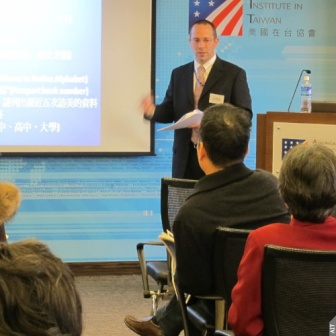Can you imagine a creative backstory for the presenter in the image? Imagine the presenter in the image is a former diplomat turned educator. He spent years working in various international roles, bridging gaps between cultures and languages. After retiring from his diplomatic career, he pursued a passion for teaching and now regularly gives lectures on global politics and international relations. His presentations are always insightful, drawing from his rich reservoir of experience and stories from around the world. Today, he is sharing his expertise with a group of students and professionals, inspiring the next generation of global leaders. What might the audience members be thinking or feeling during the presentation? The audience members are likely feeling a mixture of curiosity and engagement. Some might be taking detailed notes, eager to learn from the presenter's extensive knowledge. Others might be reflecting on their own experiences and considering how the information presented applies to their personal or professional lives. There could also be a sense of appreciation for the presenter's ability to communicate across cultures, making complex topics accessible to everyone in the room. 